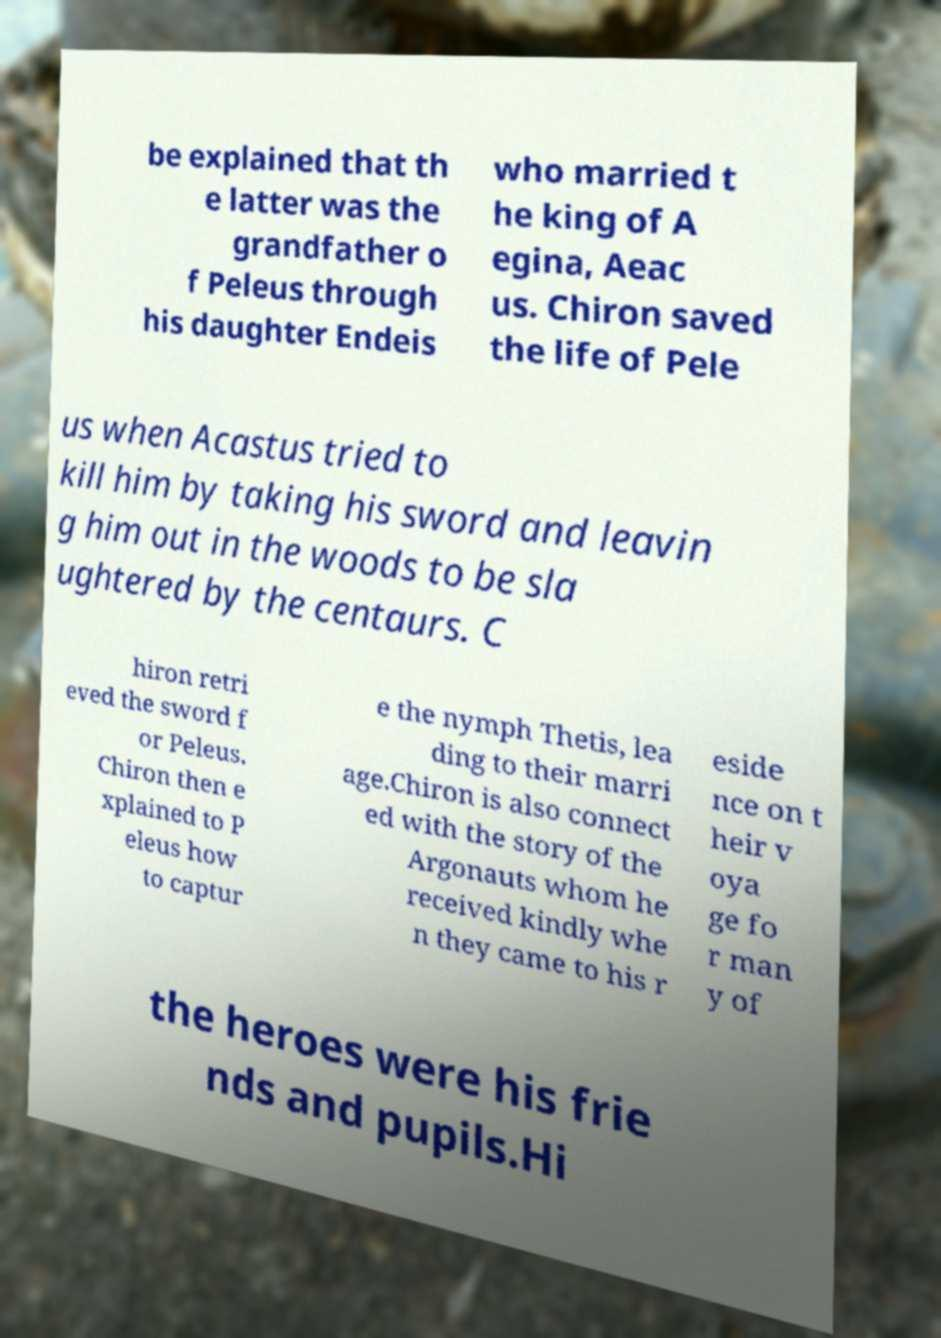Please identify and transcribe the text found in this image. be explained that th e latter was the grandfather o f Peleus through his daughter Endeis who married t he king of A egina, Aeac us. Chiron saved the life of Pele us when Acastus tried to kill him by taking his sword and leavin g him out in the woods to be sla ughtered by the centaurs. C hiron retri eved the sword f or Peleus. Chiron then e xplained to P eleus how to captur e the nymph Thetis, lea ding to their marri age.Chiron is also connect ed with the story of the Argonauts whom he received kindly whe n they came to his r eside nce on t heir v oya ge fo r man y of the heroes were his frie nds and pupils.Hi 